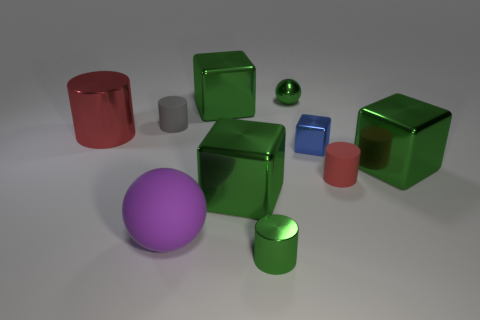Subtract all tiny cylinders. How many cylinders are left? 1 Subtract all yellow cylinders. How many green blocks are left? 3 Subtract all cylinders. How many objects are left? 6 Subtract all green cylinders. How many cylinders are left? 3 Subtract 0 blue balls. How many objects are left? 10 Subtract all yellow spheres. Subtract all yellow blocks. How many spheres are left? 2 Subtract all purple metal cubes. Subtract all gray rubber things. How many objects are left? 9 Add 4 large green metallic things. How many large green metallic things are left? 7 Add 9 big gray matte objects. How many big gray matte objects exist? 9 